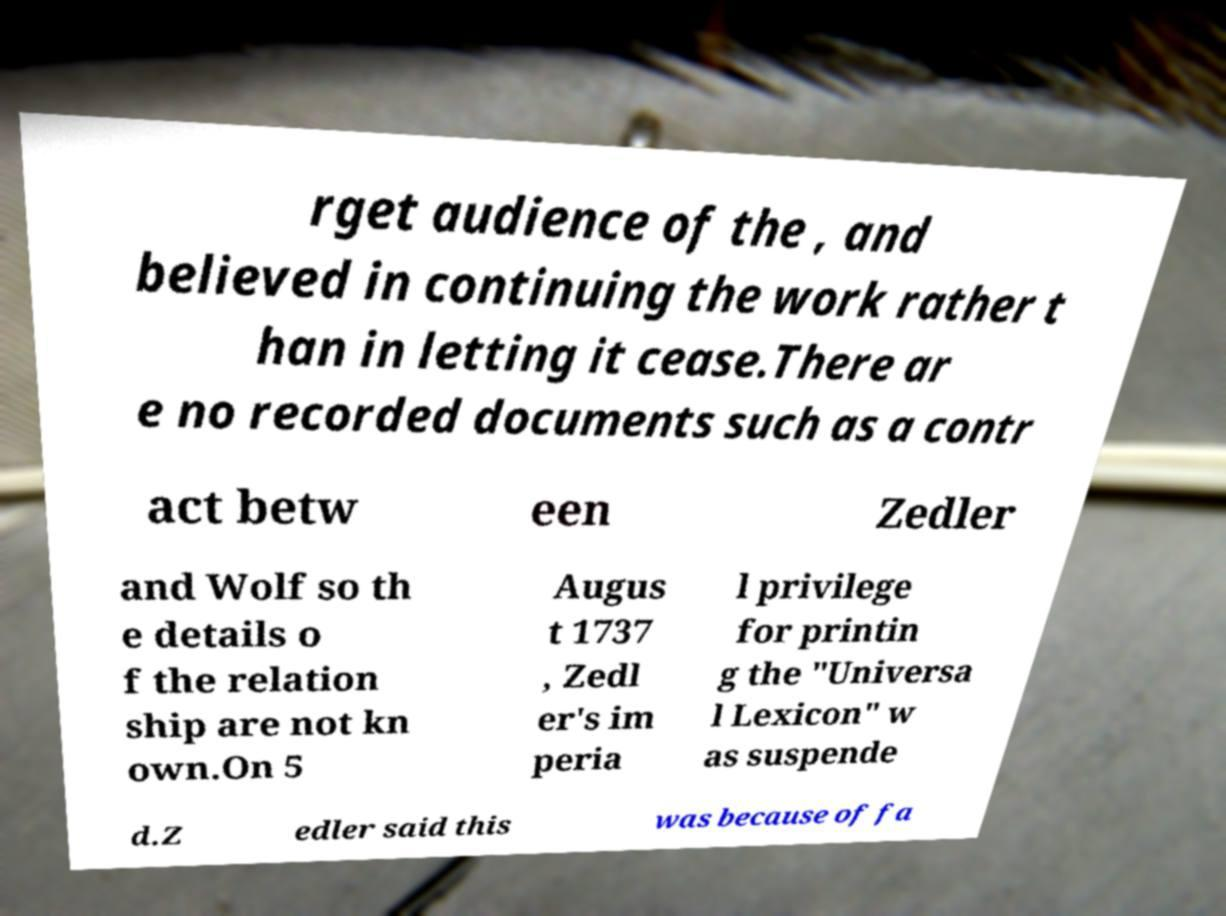Can you read and provide the text displayed in the image?This photo seems to have some interesting text. Can you extract and type it out for me? rget audience of the , and believed in continuing the work rather t han in letting it cease.There ar e no recorded documents such as a contr act betw een Zedler and Wolf so th e details o f the relation ship are not kn own.On 5 Augus t 1737 , Zedl er's im peria l privilege for printin g the "Universa l Lexicon" w as suspende d.Z edler said this was because of fa 